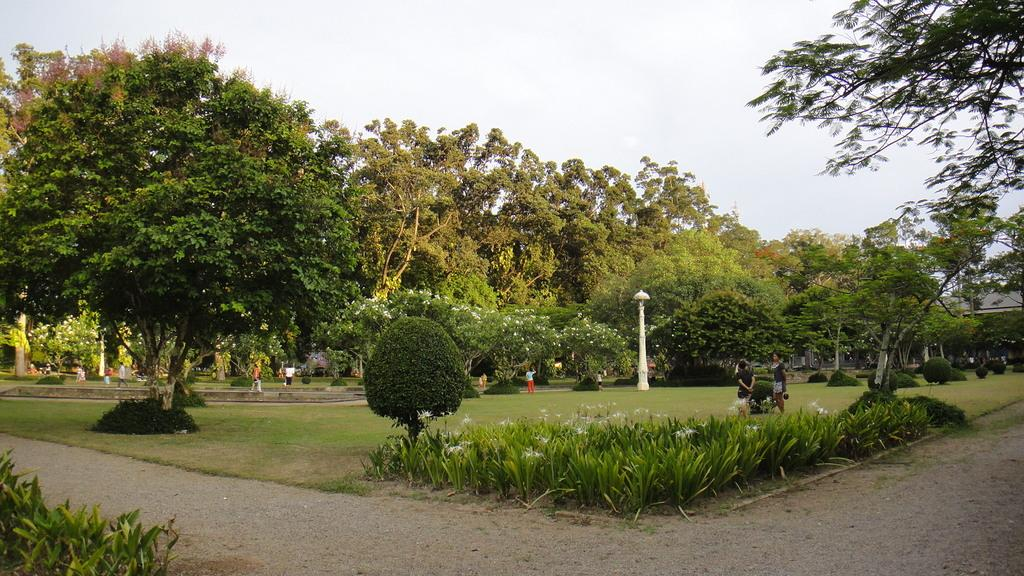What type of vegetation is present in the image? There are many trees, flowers, and plants in the image. What are the people in the image doing? The people are on the grass in the image. What else can be seen in the image besides vegetation and people? There is a road visible in the image. What type of nut is being used to cook in the image? There is no nut or cooking activity present in the image. What color is the dress worn by the person in the image? There are no people wearing dresses in the image. 